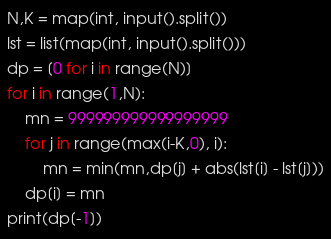<code> <loc_0><loc_0><loc_500><loc_500><_Python_>N,K = map(int, input().split())
lst = list(map(int, input().split()))
dp = [0 for i in range(N)]
for i in range(1,N):
    mn = 999999999999999999
    for j in range(max(i-K,0), i):
        mn = min(mn,dp[j] + abs(lst[i] - lst[j]))
    dp[i] = mn
print(dp[-1])</code> 